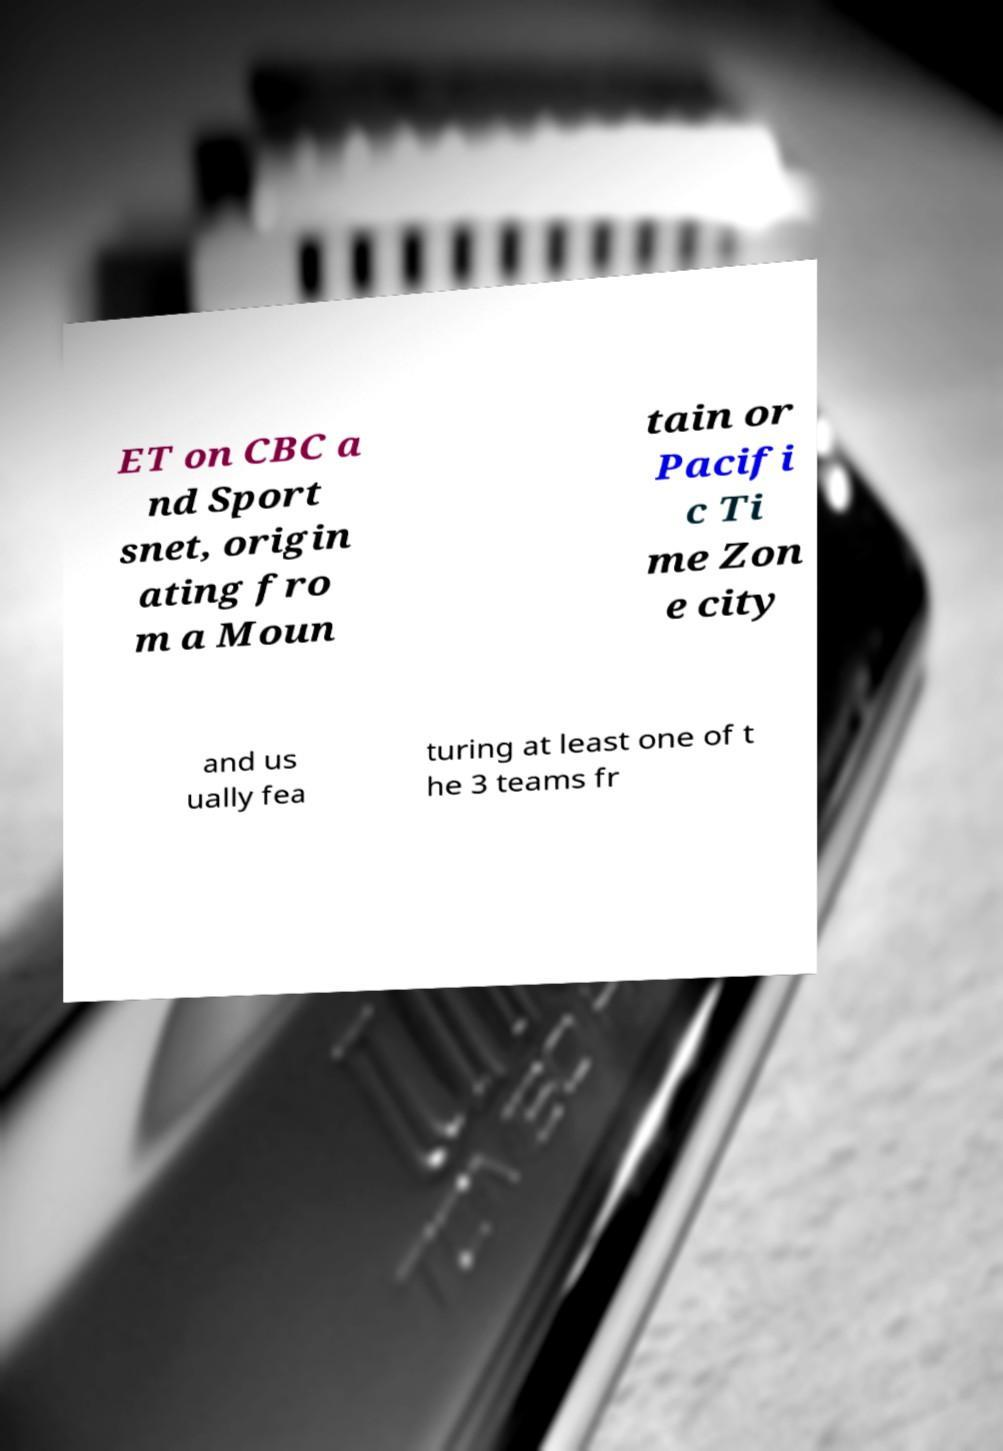Please read and relay the text visible in this image. What does it say? ET on CBC a nd Sport snet, origin ating fro m a Moun tain or Pacifi c Ti me Zon e city and us ually fea turing at least one of t he 3 teams fr 